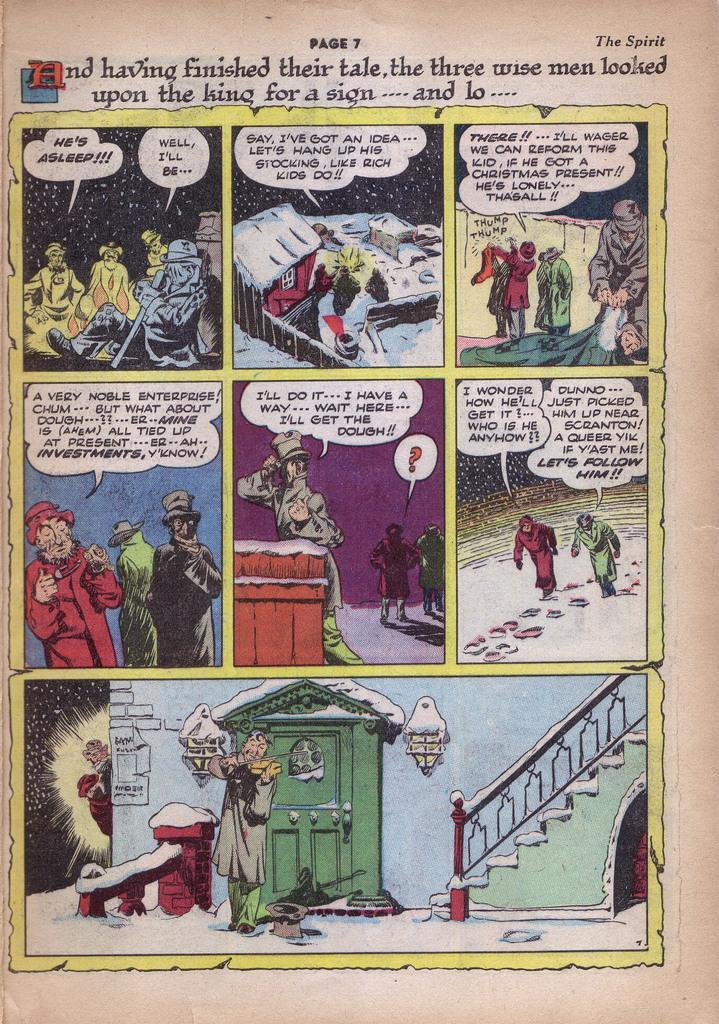<image>
Summarize the visual content of the image. A page seven of a comic book called The Spirit. 